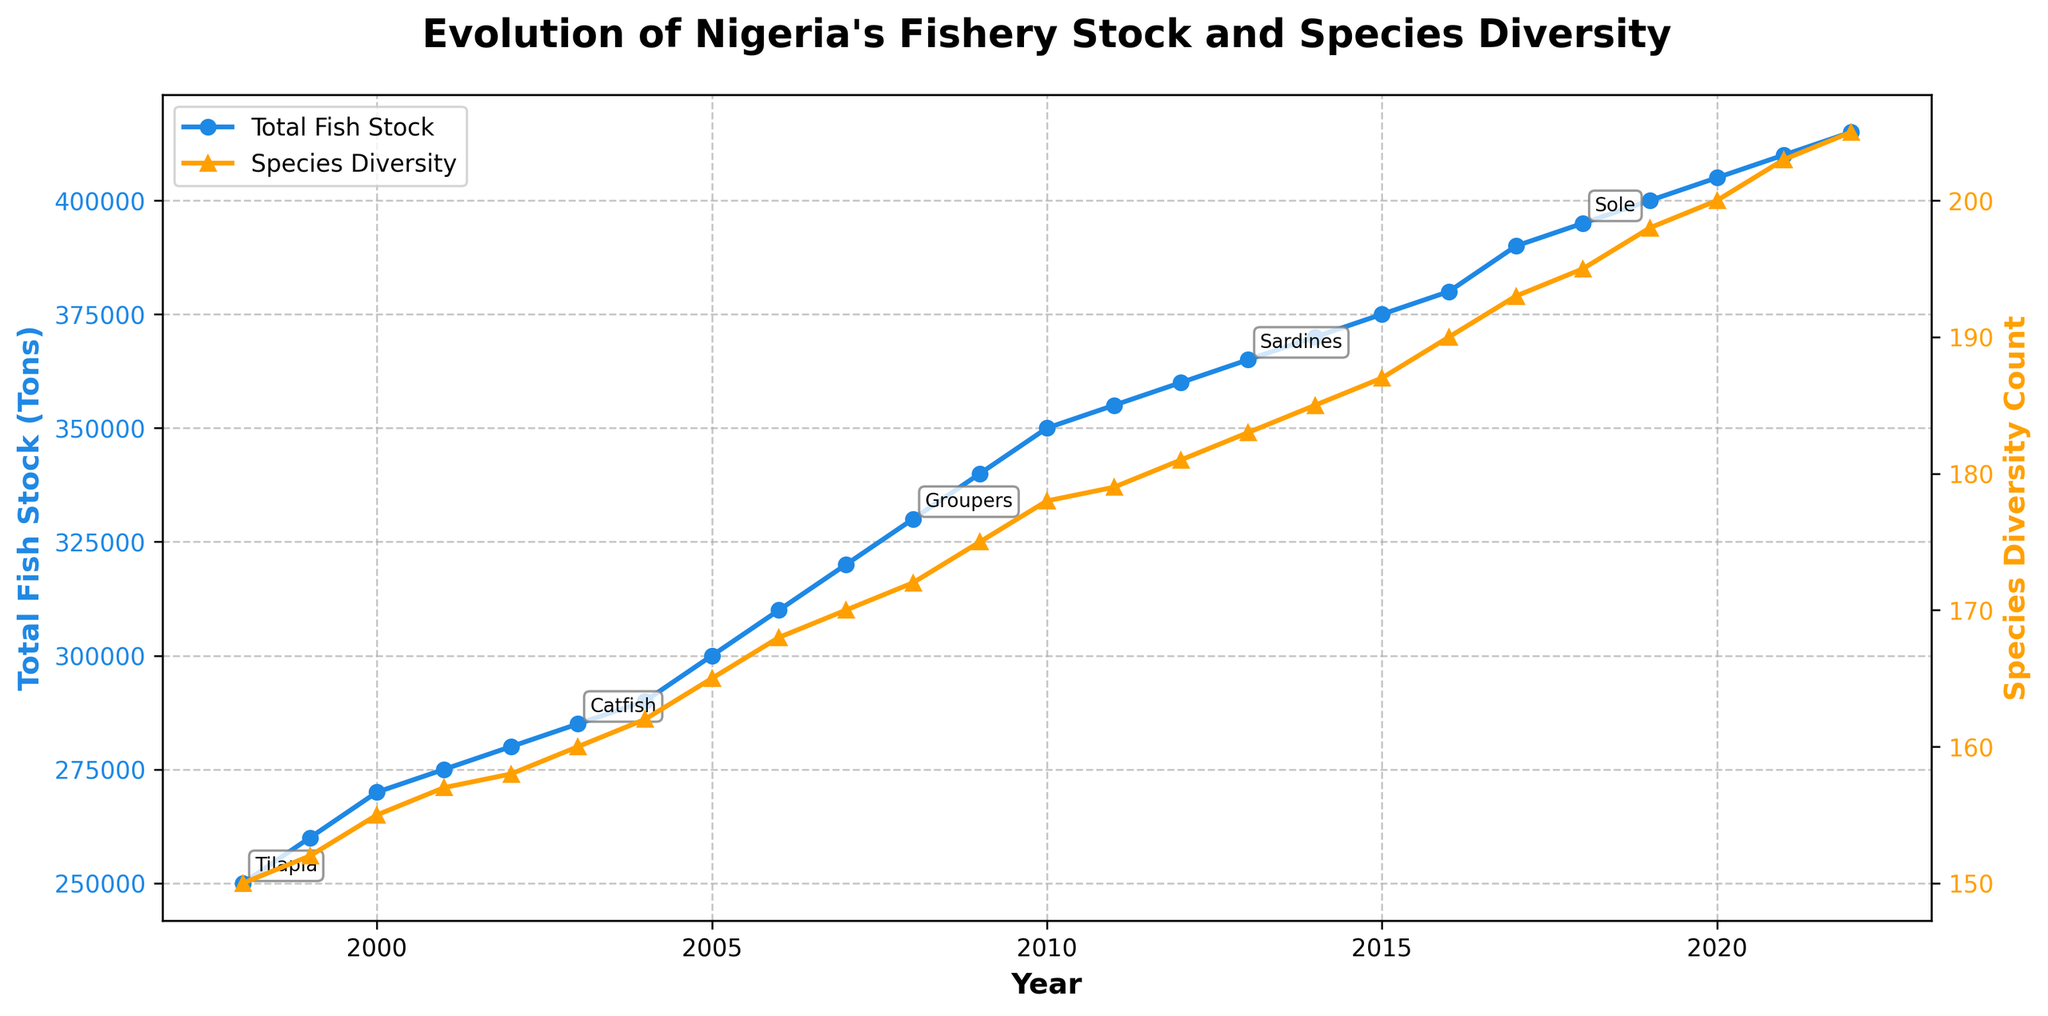What is the title of the plot? The title is prominently displayed at the top of the plot and states, "Evolution of Nigeria's Fishery Stock and Species Diversity".
Answer: Evolution of Nigeria's Fishery Stock and Species Diversity What colors represent the Total Fish Stock and Species Diversity in the plot? The plot uses distinct colors for each metric: blue for Total Fish Stock and orange for Species Diversity, as seen in the lines and labels.
Answer: Blue and orange Between which years does the time series plot span? The x-axis of the plot shows the range of years from the start to the end of the data, which are 1998 and 2022 respectively.
Answer: 1998 to 2022 How many data points are there in the plot? The number of data points corresponds to the number of years shown in the x-axis, from 1998 to 2022. This period covers 25 years, hence there are 25 data points.
Answer: 25 What notable species appeared for the first time in 2001? The annotations on the plot highlight notable species for different years. Barracuda is the species first seen in 2001.
Answer: Barracuda In which year did Nigeria’s fish stock surpass 300,000 tons? The Total Fish Stock line crosses the 300,000 tons mark between 2004 and 2005. The first year it surpasses this value is 2005.
Answer: 2005 What is the difference in species diversity count between 1998 and 2022? The species diversity count is listed at 150 in 1998 and 205 in 2022. The difference is calculated by subtracting the two values: 205 - 150 = 55.
Answer: 55 Which year recorded the highest total fish stock? The highest point on the Total Fish Stock line is visible at the rightmost end of the plot, corresponding to the year 2022 with a stock level of 415,000 tons.
Answer: 2022 By how much did the total fish stock increase from 2000 to 2015? The total fish stock in 2000 is 270,000 tons, and in 2015 it is 375,000 tons. The increase is calculated by subtraction: 375,000 - 270,000 = 105,000 tons.
Answer: 105,000 tons What is the general trend observed for species diversity count over 25 years? The species diversity count shows an upward trend throughout the 25 years, as indicated by the steadily increasing line.
Answer: Upward trend 